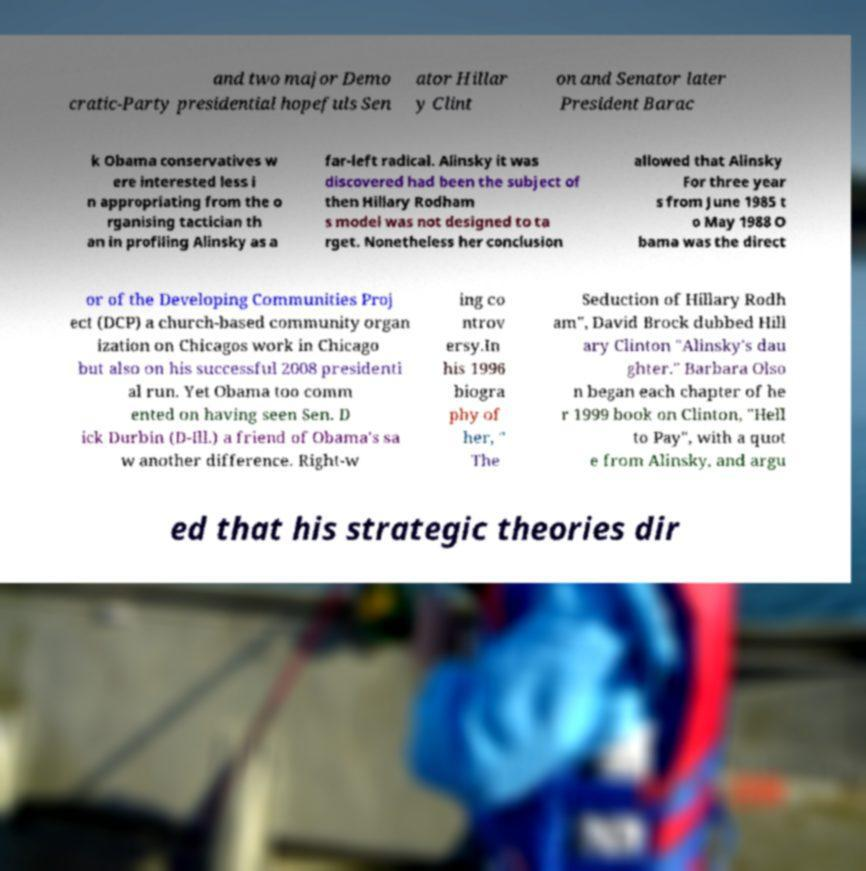I need the written content from this picture converted into text. Can you do that? and two major Demo cratic-Party presidential hopefuls Sen ator Hillar y Clint on and Senator later President Barac k Obama conservatives w ere interested less i n appropriating from the o rganising tactician th an in profiling Alinsky as a far-left radical. Alinsky it was discovered had been the subject of then Hillary Rodham s model was not designed to ta rget. Nonetheless her conclusion allowed that Alinsky For three year s from June 1985 t o May 1988 O bama was the direct or of the Developing Communities Proj ect (DCP) a church-based community organ ization on Chicagos work in Chicago but also on his successful 2008 presidenti al run. Yet Obama too comm ented on having seen Sen. D ick Durbin (D-Ill.) a friend of Obama's sa w another difference. Right-w ing co ntrov ersy.In his 1996 biogra phy of her, " The Seduction of Hillary Rodh am", David Brock dubbed Hill ary Clinton "Alinsky's dau ghter." Barbara Olso n began each chapter of he r 1999 book on Clinton, "Hell to Pay", with a quot e from Alinsky, and argu ed that his strategic theories dir 